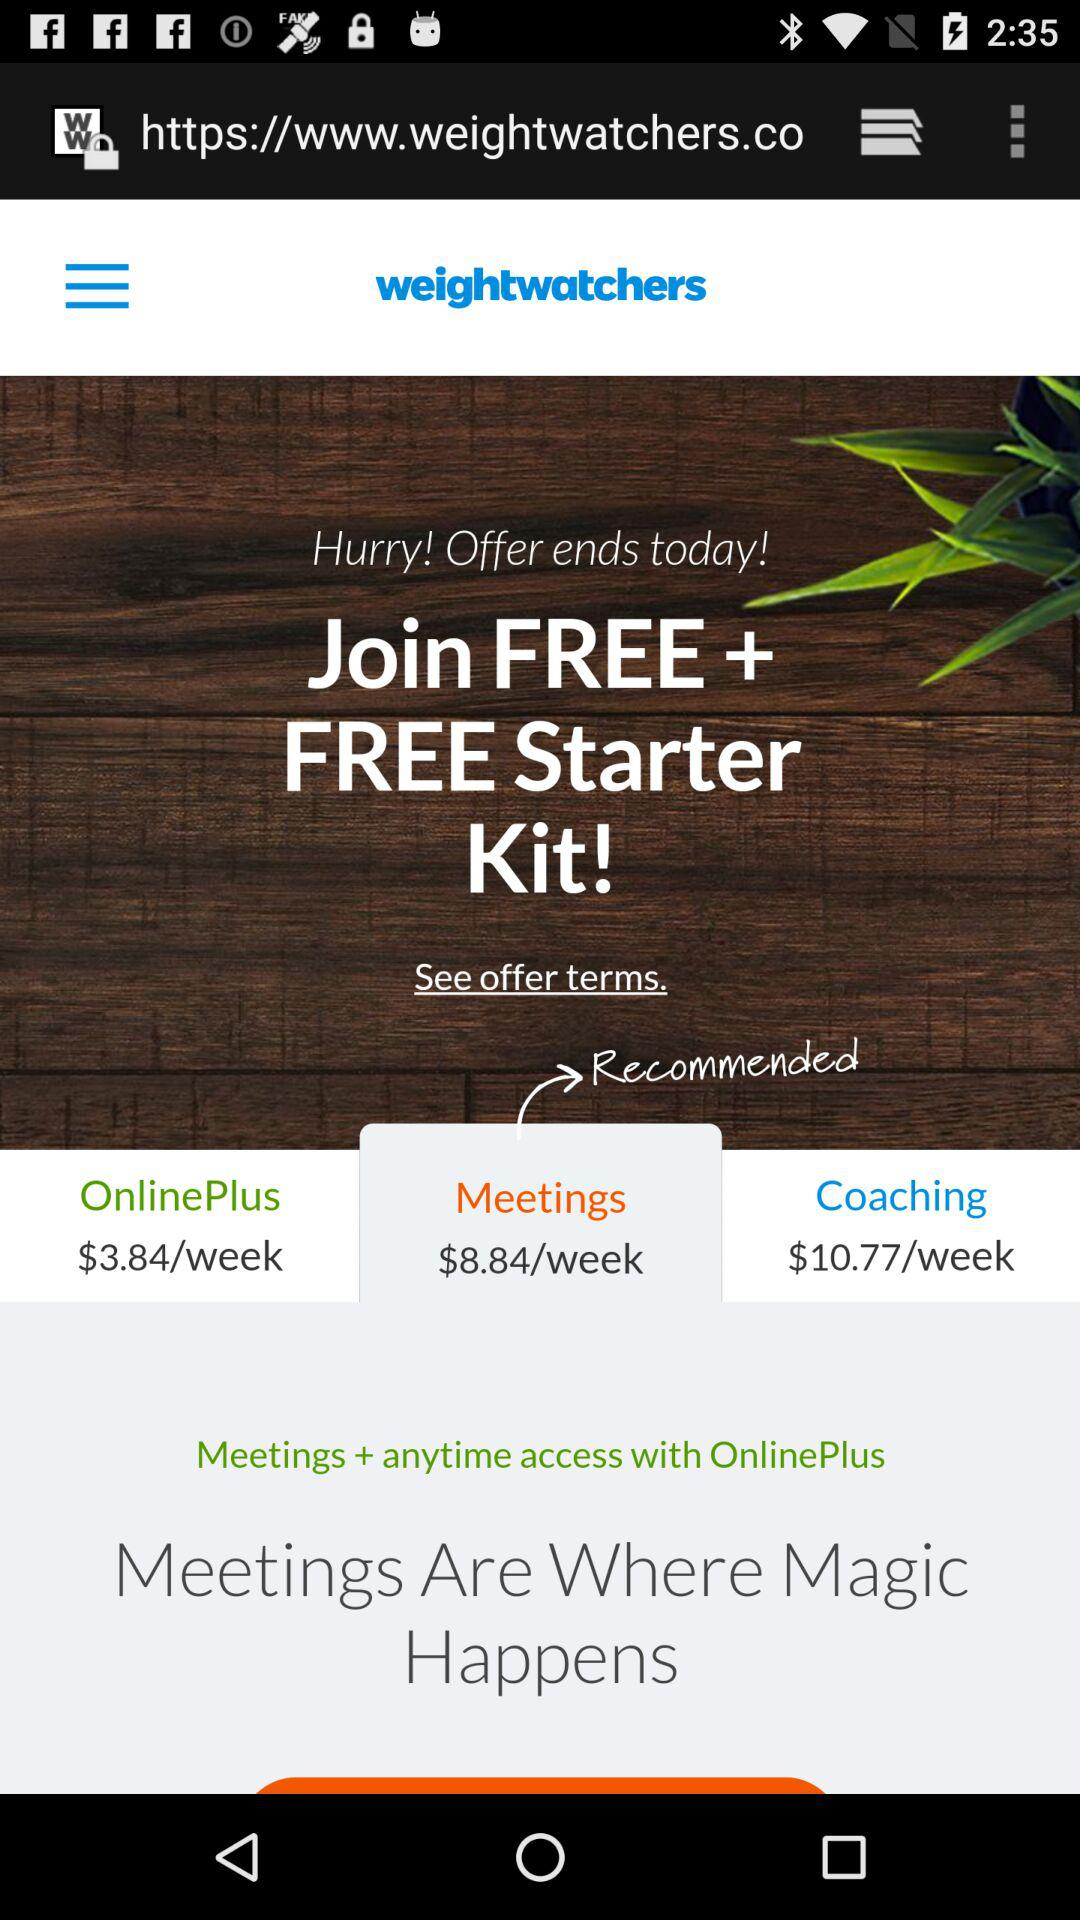What is the price for the "Meetings"? The price for the "Meetings" is $8.84 per week. 